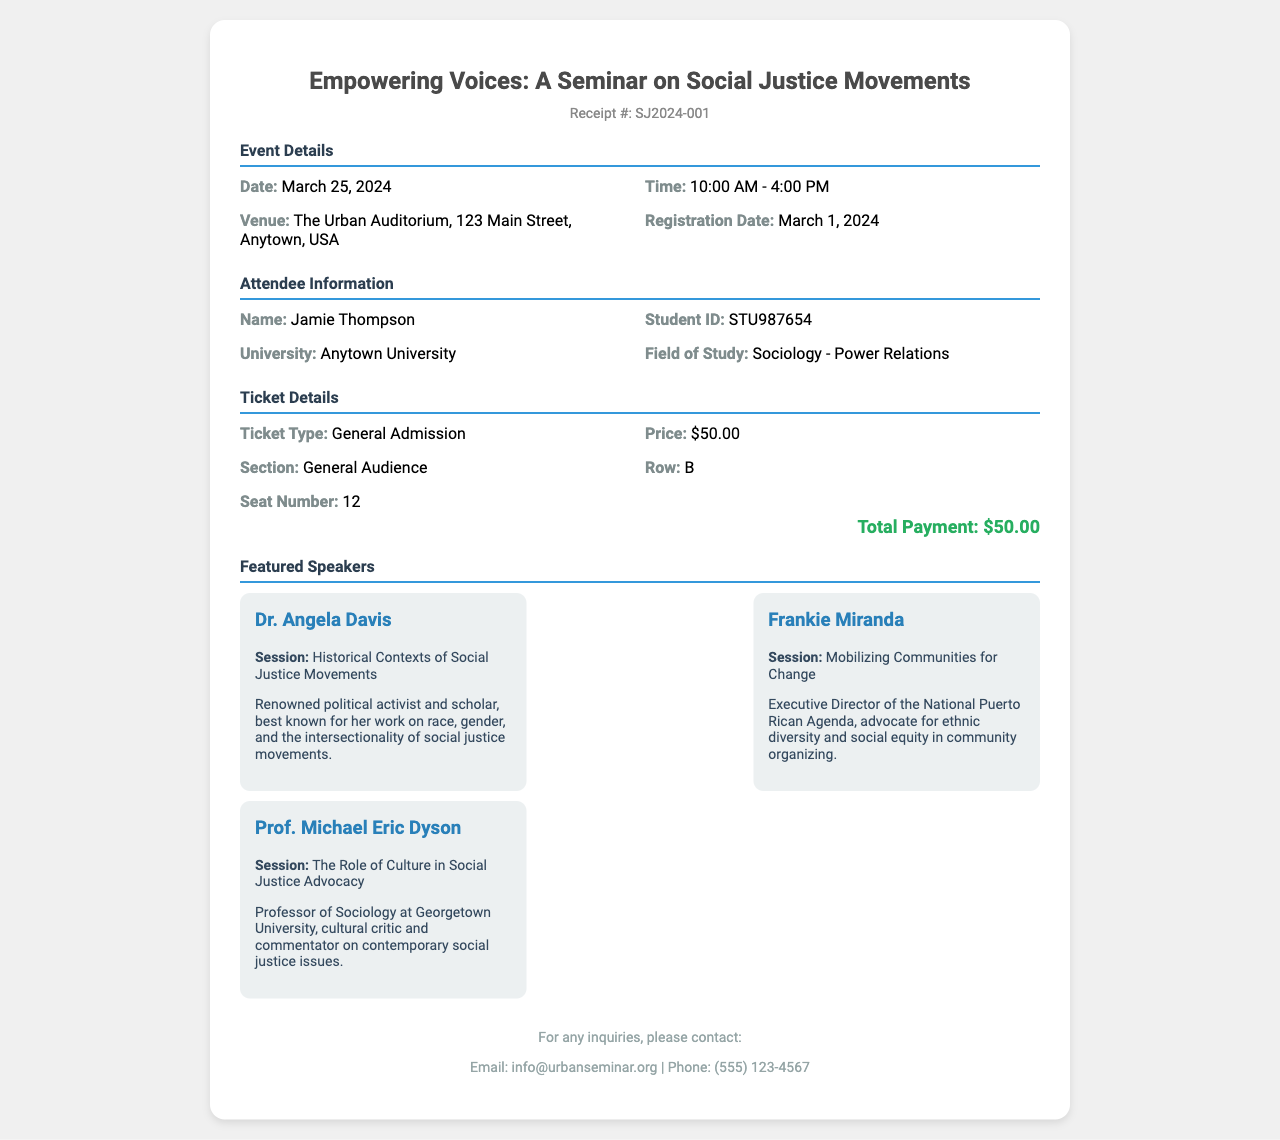What is the name of the seminar? The seminar is titled "Empowering Voices: A Seminar on Social Justice Movements."
Answer: Empowering Voices: A Seminar on Social Justice Movements What is the date of the event? The event is scheduled for March 25, 2024.
Answer: March 25, 2024 Who is the first featured speaker? The first featured speaker listed in the document is Dr. Angela Davis.
Answer: Dr. Angela Davis What is the price of the ticket? The ticket price mentioned in the receipt is $50.00.
Answer: $50.00 What section and row can the attendee be found in? The attendee's seat is in the General Audience section, Row B.
Answer: General Audience, Row B What is the total payment for the ticket? The total payment for the ticket is specified at the bottom of the ticket details section.
Answer: $50.00 How many speakers are featured in the seminar? There are three featured speakers mentioned in the document.
Answer: Three What time does the seminar start? The seminar starts at 10:00 AM.
Answer: 10:00 AM Who should be contacted for inquiries? For inquiries, the contact email provided is info@urbanseminar.org.
Answer: info@urbanseminar.org 